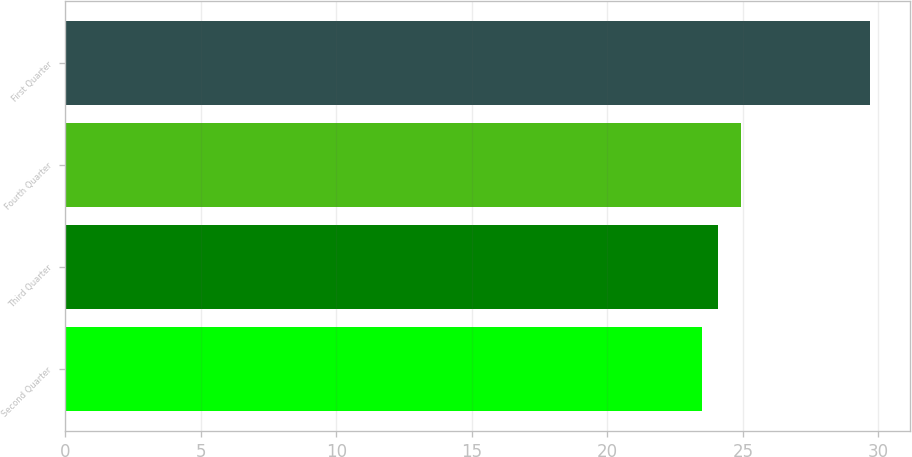Convert chart to OTSL. <chart><loc_0><loc_0><loc_500><loc_500><bar_chart><fcel>Second Quarter<fcel>Third Quarter<fcel>Fourth Quarter<fcel>First Quarter<nl><fcel>23.48<fcel>24.1<fcel>24.92<fcel>29.7<nl></chart> 